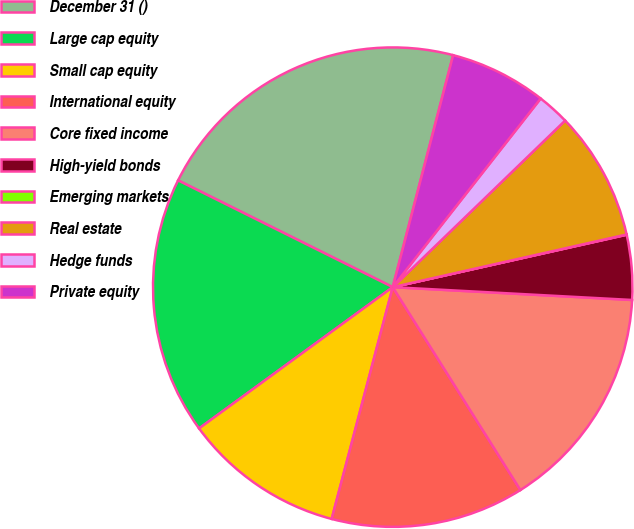Convert chart. <chart><loc_0><loc_0><loc_500><loc_500><pie_chart><fcel>December 31 ()<fcel>Large cap equity<fcel>Small cap equity<fcel>International equity<fcel>Core fixed income<fcel>High-yield bonds<fcel>Emerging markets<fcel>Real estate<fcel>Hedge funds<fcel>Private equity<nl><fcel>21.71%<fcel>17.38%<fcel>10.87%<fcel>13.04%<fcel>15.21%<fcel>4.36%<fcel>0.02%<fcel>8.7%<fcel>2.19%<fcel>6.53%<nl></chart> 